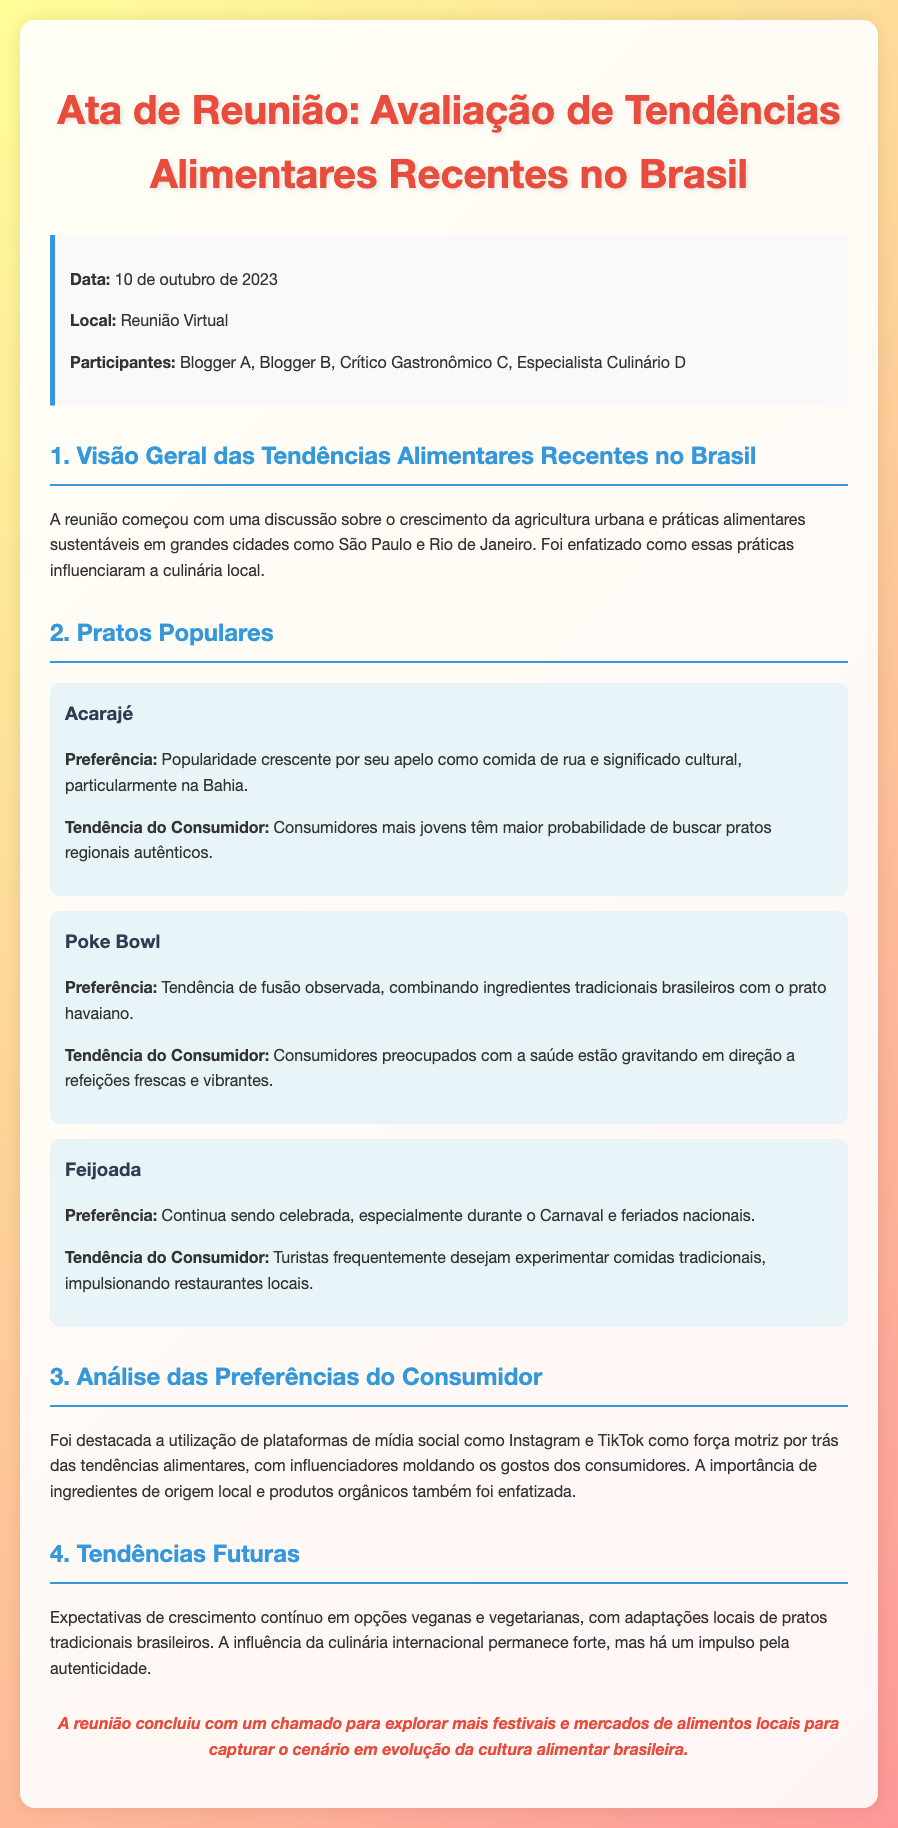Qual é a data da reunião? A data da reunião é mencionada na seção de informações, que é 10 de outubro de 2023.
Answer: 10 de outubro de 2023 Quem foi um dos participantes da reunião? A lista de participantes inclui Blogger A, Blogger B, Crítico Gastronômico C, e Especialista Culinário D. Portanto, um deles pode ser qualquer um citado.
Answer: Blogger A Qual prato continua sendo celebrado especialmente durante o Carnaval? O prato mencionado na seção sobre pratos populares que é celebrado durante o Carnaval é a Feijoada.
Answer: Feijoada Qual é a tendência observada em relação ao Acarajé? A tendência descrita para o Acarajé gira em torno de sua popularidade crescente devido ao seu apelo como comida de rua e significado cultural.
Answer: Popularidade crescente Que plataformas de mídia social foram destacadas na análise das preferências do consumidor? As plataformas mencionadas que influenciam as tendências alimentares são Instagram e TikTok.
Answer: Instagram e TikTok O que se espera em relação às opções veganas e vegetarianas no futuro? O documento menciona expectativas de crescimento contínuo nas opções veganas e vegetarianas, reforçando a tendência de adaptações locais.
Answer: Crescimento contínuo Quais práticas alimentares foram discutidas no início da reunião? O início da reunião teve uma discussão sobre o crescimento da agricultura urbana e práticas alimentares sustentáveis.
Answer: Agricultura urbana e práticas alimentares sustentáveis O que a reunião concluiu sobre a cultura alimentar brasileira? A conclusão da reunião destaca a necessidade de explorar mais festivais e mercados de alimentos locais.
Answer: Festivais e mercados de alimentos locais 